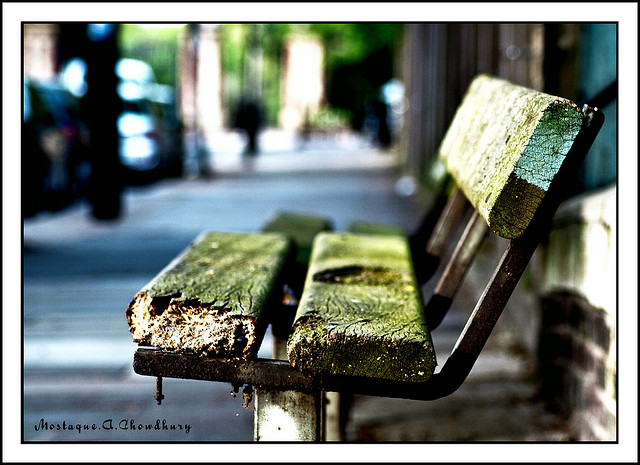Identify and read out the text in this image. Mostaque Chow&amp;hury 